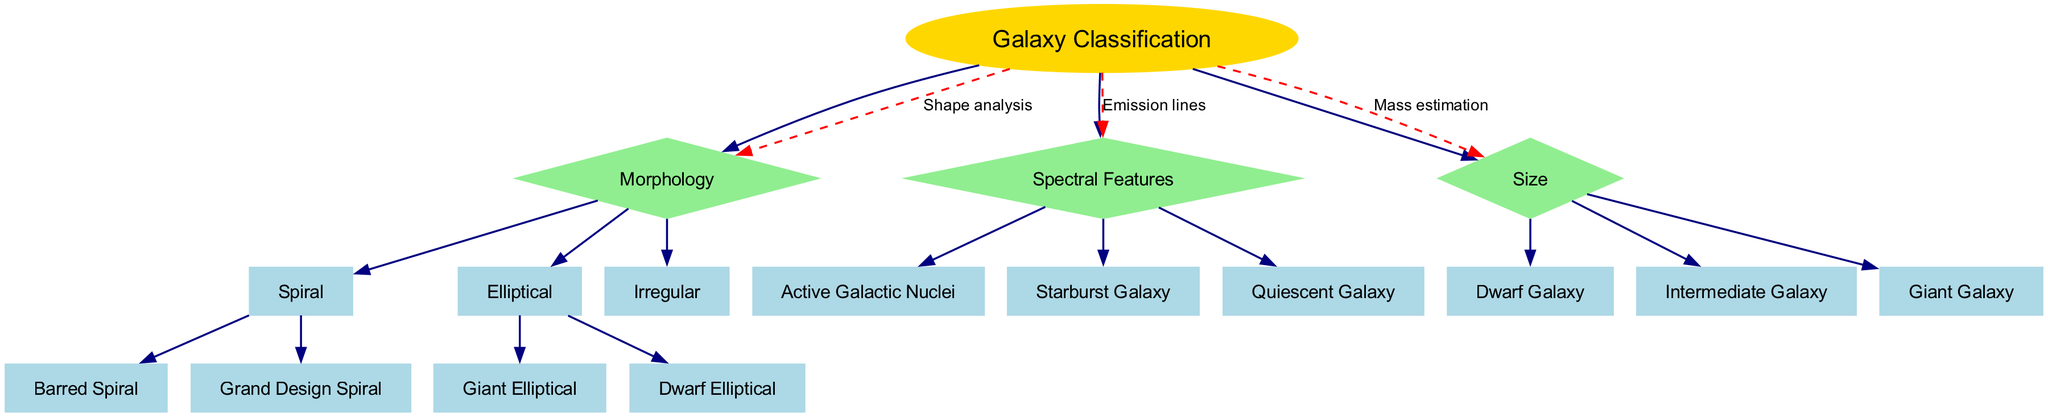What is the root node of this decision tree? The root node is labeled "Galaxy Classification," which acts as the starting point for all subsequent node classifications in the diagram.
Answer: Galaxy Classification How many main categories are there under "Galaxy Classification"? There are three main categories (or nodes) stemming from "Galaxy Classification": Morphology, Spectral Features, and Size.
Answer: 3 Which type of galaxy is a child of the Morphology node? The "Spiral" type is a direct child of the Morphology node, displaying one of the galaxy classifications based on shape.
Answer: Spiral What are the two types of galaxies that fall under the Elliptical category? The two types are "Giant Elliptical" and "Dwarf Elliptical," which are both classified under the Elliptical morphology in the diagram.
Answer: Giant Elliptical, Dwarf Elliptical What is the relationship between the "Galaxy Classification" node and the "Size" node? The relationship is described as "Mass estimation," indicating that size classification is determined based on the mass of the galaxy.
Answer: Mass estimation How many children does the Spectral Features node have? The Spectral Features node has three children: Active Galactic Nuclei, Starburst Galaxy, and Quiescent Galaxy, categorizing different types based on their spectral characteristics.
Answer: 3 How is the "Barred Spiral" galaxy type categorized in the diagram? The "Barred Spiral" galaxy is categorized under the "Spiral" type, which is a subclassification of the Morphology node indicating a specific shape.
Answer: Barred Spiral Which galaxy type is linked to the characteristic of having active emissions? The characteristic of having active emissions is linked to the Active Galactic Nuclei, which is a child of the Spectral Features node.
Answer: Active Galactic Nuclei What connects the "Galaxy Classification" node to the "Morphology" node? The connection is labeled as "Shape analysis," representing how shape is analyzed to classify galaxies within the decision tree.
Answer: Shape analysis 